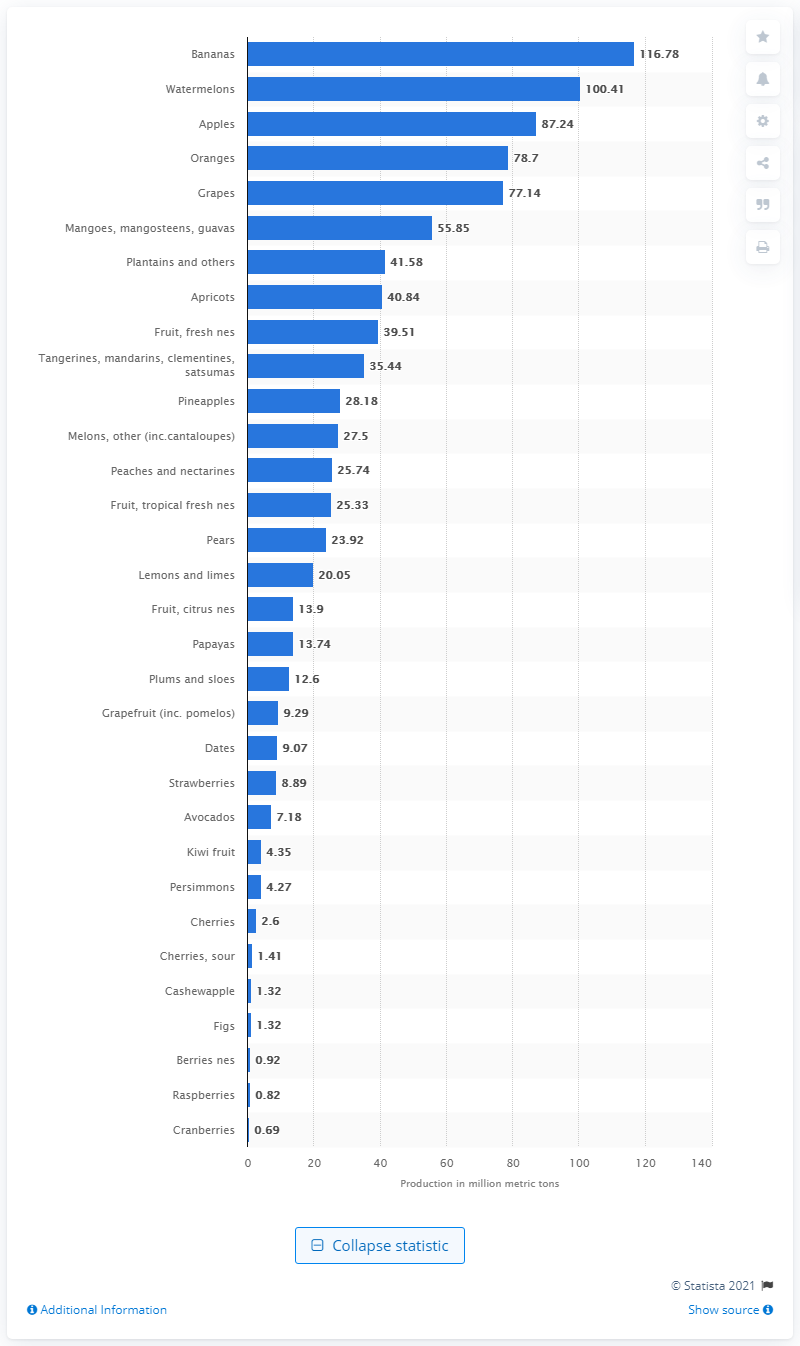Specify some key components in this picture. In 2019, a total of 116,780 metric tons of bananas were produced worldwide. 